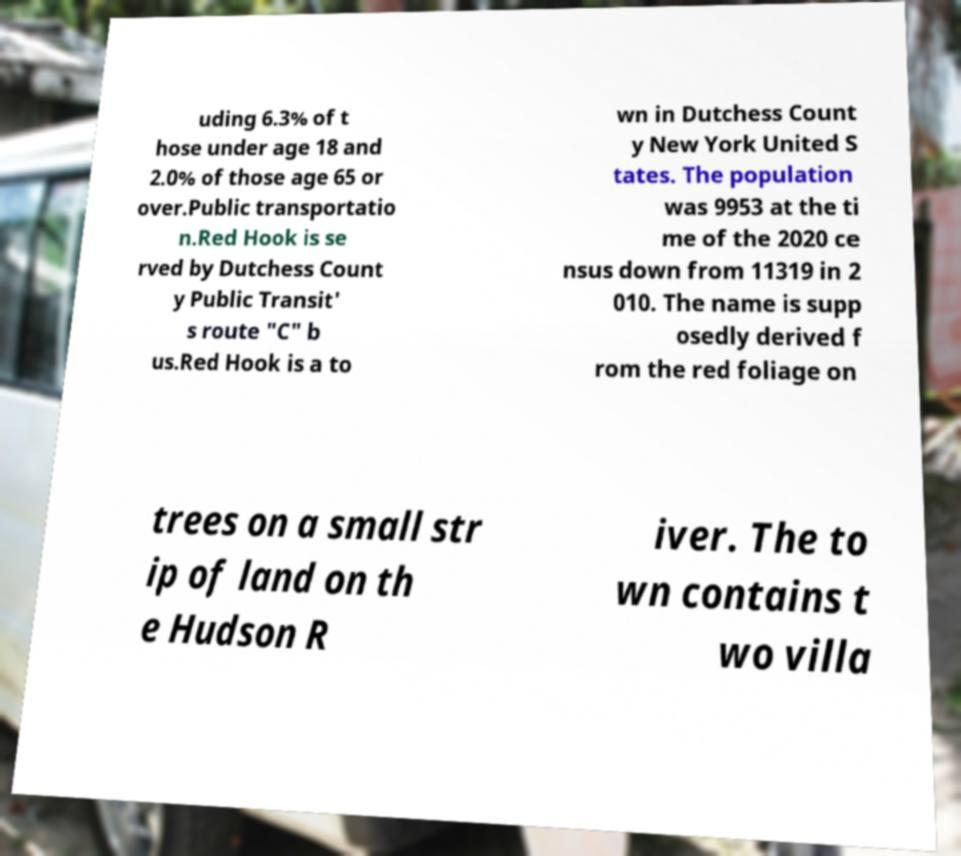Could you assist in decoding the text presented in this image and type it out clearly? uding 6.3% of t hose under age 18 and 2.0% of those age 65 or over.Public transportatio n.Red Hook is se rved by Dutchess Count y Public Transit' s route "C" b us.Red Hook is a to wn in Dutchess Count y New York United S tates. The population was 9953 at the ti me of the 2020 ce nsus down from 11319 in 2 010. The name is supp osedly derived f rom the red foliage on trees on a small str ip of land on th e Hudson R iver. The to wn contains t wo villa 